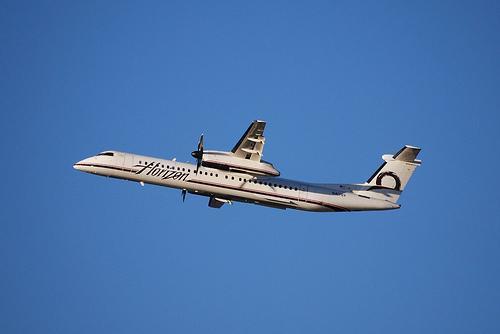How many airplanes are there?
Give a very brief answer. 1. 